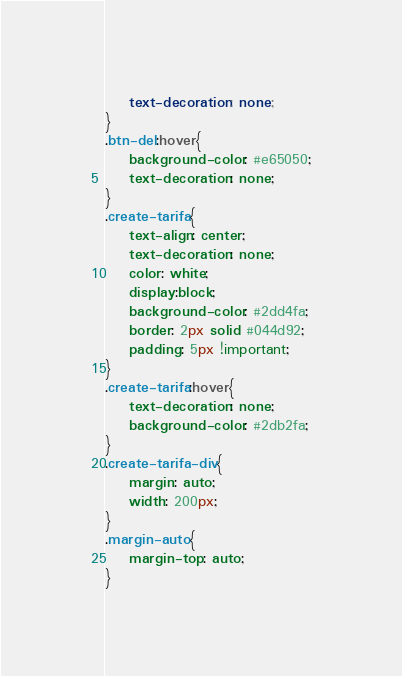Convert code to text. <code><loc_0><loc_0><loc_500><loc_500><_CSS_>    text-decoration: none;
}
.btn-del:hover{
    background-color: #e65050;
    text-decoration: none;
}
.create-tarifa{
    text-align: center;
    text-decoration: none;
    color: white;
    display:block;
    background-color: #2dd4fa;
    border: 2px solid #044d92;
    padding: 5px !important;
}
.create-tarifa:hover{
    text-decoration: none;
    background-color: #2db2fa;
}
.create-tarifa-div{
    margin: auto;
    width: 200px;
}
.margin-auto{
    margin-top: auto;
}</code> 